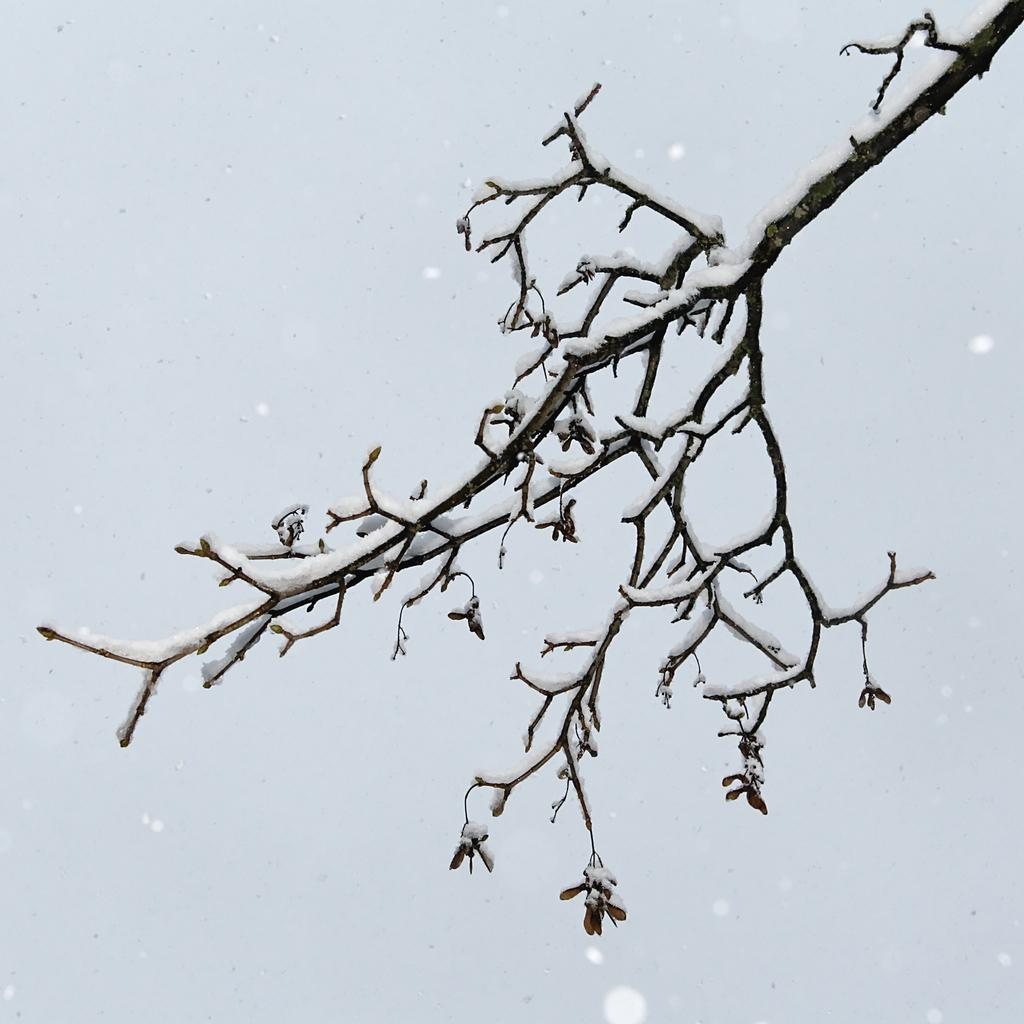What is the main object in the image? There is a small branch of a tree in the image. What is covering the branch? The branch is covered with snow. What color is the background of the image? The background of the image is white. Can you hear the coil making a sound in the image? There is no coil present in the image, so it cannot make any sound. 